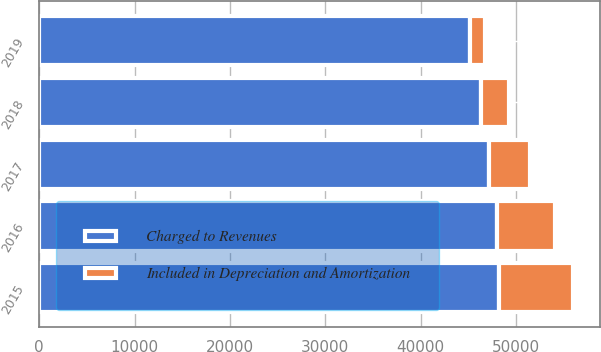<chart> <loc_0><loc_0><loc_500><loc_500><stacked_bar_chart><ecel><fcel>2015<fcel>2016<fcel>2017<fcel>2018<fcel>2019<nl><fcel>Charged to Revenues<fcel>48230<fcel>48040<fcel>47192<fcel>46389<fcel>45189<nl><fcel>Included in Depreciation and Amortization<fcel>7748<fcel>6073<fcel>4280<fcel>2838<fcel>1554<nl></chart> 